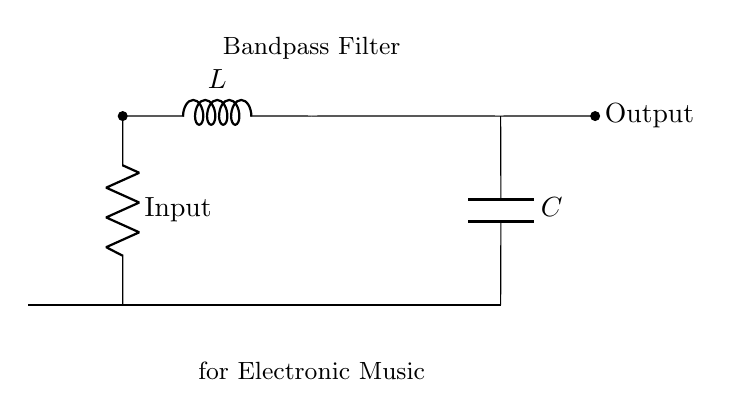What components are in this circuit? The circuit contains a resistor, an inductor, and a capacitor, which are essential for creating the bandpass filter functionality.
Answer: Resistor, Inductor, Capacitor What is the function of this circuit? This circuit is designed as a bandpass filter, which allows specific frequencies to pass through while attenuating others. This makes it suitable for isolating particular frequency ranges in electronic music.
Answer: Bandpass filter What is the input connection labeled as? The input connection is labeled at the resistor component, indicating where the signal enters the circuit.
Answer: Input How many components are in series? The resistor, inductor, and capacitor are arranged in a combination that involves series and parallel connections. However, focusing specifically on the direct series part, the resistor and inductor are in series with the capacitor connected in parallel. Thus, the series count is two.
Answer: Two What is the purpose of the capacitor in this circuit? The capacitor, in combination with the inductor, creates a resonant circuit that helps refine the frequency response, allowing specific frequencies to pass while blocking others. This is a crucial function in filter circuits.
Answer: Frequency refinement What happens to the output regarding frequency input? The output will only pass frequencies within a certain range defined by the resistor, inductor, and capacitor values, while other frequencies will be attenuated. This selective output is key for the desired electronic music effects.
Answer: Specific frequency output What type of filter configuration is shown here? This is a series bandpass filter configuration as it employs both inductor and capacitor in a manner that allows for bandpass characteristics, focusing on specific frequencies.
Answer: Series bandpass filter 